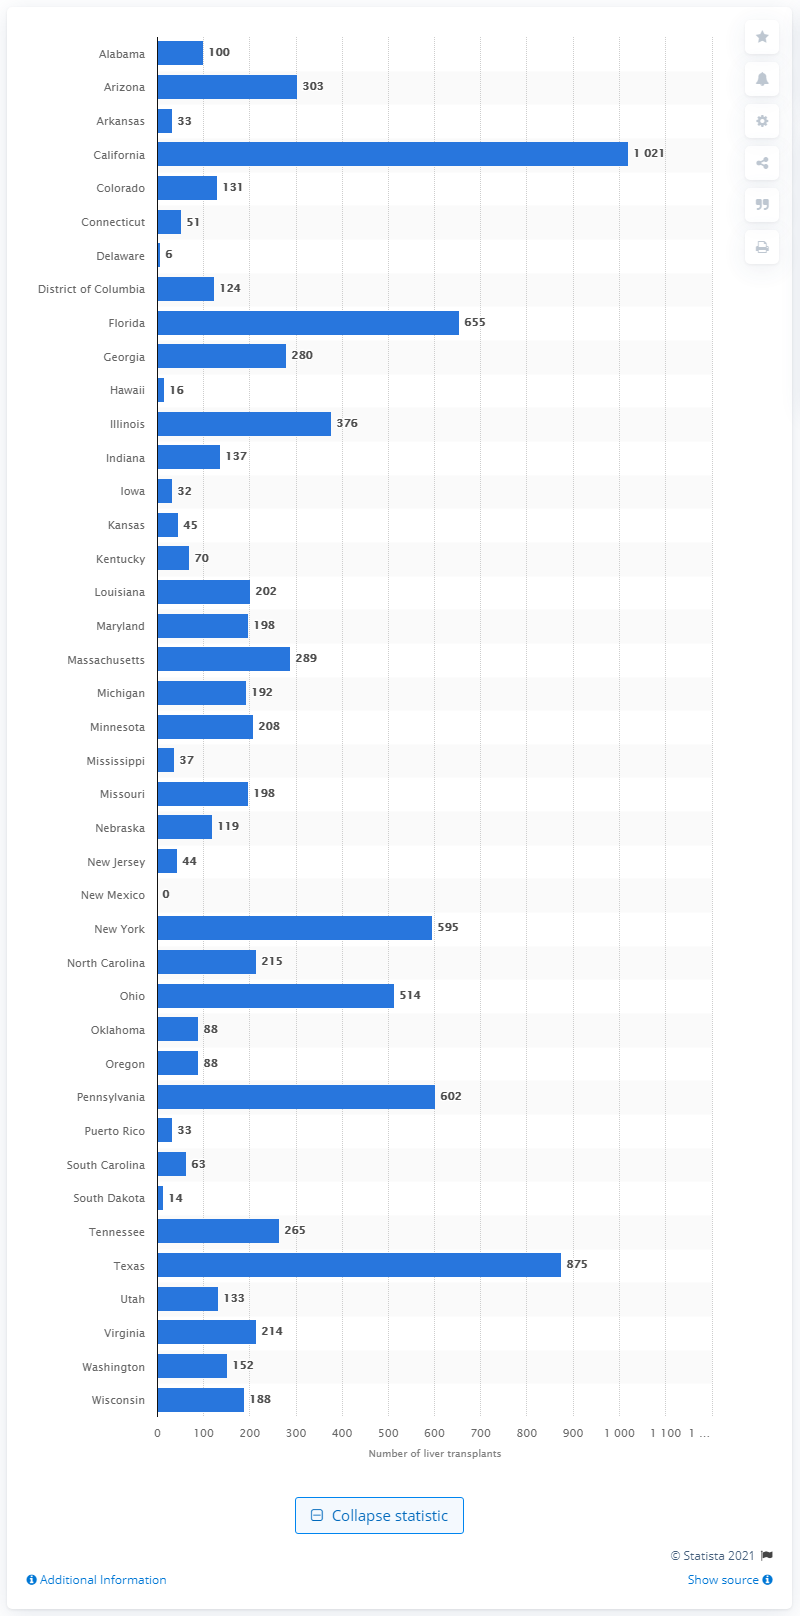Identify some key points in this picture. In 2020, a total of 303 liver transplants were performed in the state of Arizona. 